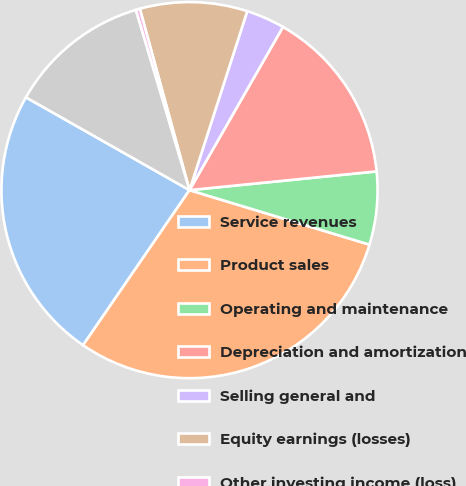<chart> <loc_0><loc_0><loc_500><loc_500><pie_chart><fcel>Service revenues<fcel>Product sales<fcel>Operating and maintenance<fcel>Depreciation and amortization<fcel>Selling general and<fcel>Equity earnings (losses)<fcel>Other investing income (loss)<fcel>Interest expense<nl><fcel>23.64%<fcel>29.89%<fcel>6.27%<fcel>15.13%<fcel>3.31%<fcel>9.22%<fcel>0.36%<fcel>12.17%<nl></chart> 